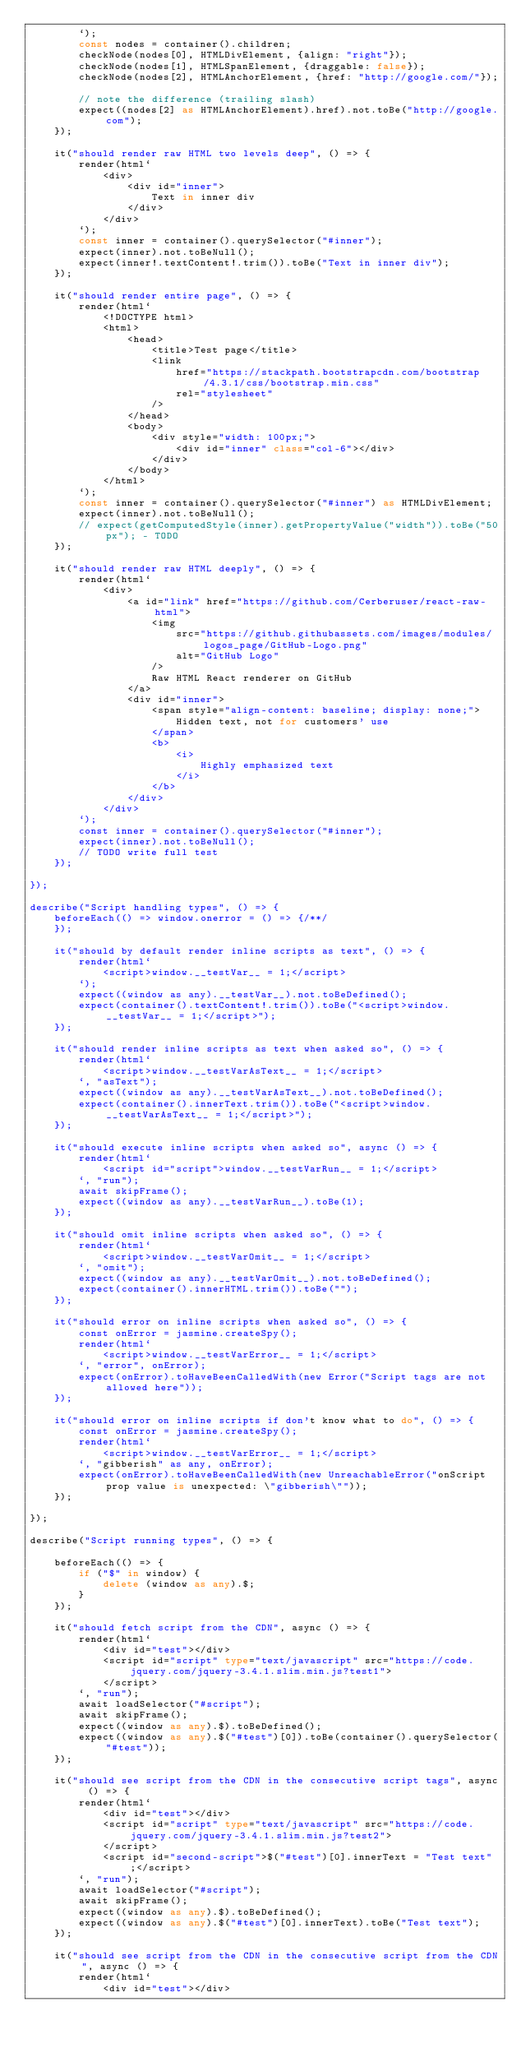Convert code to text. <code><loc_0><loc_0><loc_500><loc_500><_TypeScript_>        `);
        const nodes = container().children;
        checkNode(nodes[0], HTMLDivElement, {align: "right"});
        checkNode(nodes[1], HTMLSpanElement, {draggable: false});
        checkNode(nodes[2], HTMLAnchorElement, {href: "http://google.com/"});

        // note the difference (trailing slash)
        expect((nodes[2] as HTMLAnchorElement).href).not.toBe("http://google.com");
    });

    it("should render raw HTML two levels deep", () => {
        render(html`
            <div>
                <div id="inner">
                    Text in inner div
                </div>
            </div>
        `);
        const inner = container().querySelector("#inner");
        expect(inner).not.toBeNull();
        expect(inner!.textContent!.trim()).toBe("Text in inner div");
    });

    it("should render entire page", () => {
        render(html`
            <!DOCTYPE html>
            <html>
                <head>
                    <title>Test page</title>
                    <link
                        href="https://stackpath.bootstrapcdn.com/bootstrap/4.3.1/css/bootstrap.min.css"
                        rel="stylesheet"
                    />
                </head>
                <body>
                    <div style="width: 100px;">
                        <div id="inner" class="col-6"></div>
                    </div>
                </body>
            </html>
        `);
        const inner = container().querySelector("#inner") as HTMLDivElement;
        expect(inner).not.toBeNull();
        // expect(getComputedStyle(inner).getPropertyValue("width")).toBe("50px"); - TODO
    });

    it("should render raw HTML deeply", () => {
        render(html`
            <div>
                <a id="link" href="https://github.com/Cerberuser/react-raw-html">
                    <img
                        src="https://github.githubassets.com/images/modules/logos_page/GitHub-Logo.png"
                        alt="GitHub Logo"
                    />
                    Raw HTML React renderer on GitHub
                </a>
                <div id="inner">
                    <span style="align-content: baseline; display: none;">
                        Hidden text, not for customers' use
                    </span>
                    <b>
                        <i>
                            Highly emphasized text
                        </i>
                    </b>
                </div>
            </div>
        `);
        const inner = container().querySelector("#inner");
        expect(inner).not.toBeNull();
        // TODO write full test
    });

});

describe("Script handling types", () => {
    beforeEach(() => window.onerror = () => {/**/
    });

    it("should by default render inline scripts as text", () => {
        render(html`
            <script>window.__testVar__ = 1;</script>
        `);
        expect((window as any).__testVar__).not.toBeDefined();
        expect(container().textContent!.trim()).toBe("<script>window.__testVar__ = 1;</script>");
    });

    it("should render inline scripts as text when asked so", () => {
        render(html`
            <script>window.__testVarAsText__ = 1;</script>
        `, "asText");
        expect((window as any).__testVarAsText__).not.toBeDefined();
        expect(container().innerText.trim()).toBe("<script>window.__testVarAsText__ = 1;</script>");
    });

    it("should execute inline scripts when asked so", async () => {
        render(html`
            <script id="script">window.__testVarRun__ = 1;</script>
        `, "run");
        await skipFrame();
        expect((window as any).__testVarRun__).toBe(1);
    });

    it("should omit inline scripts when asked so", () => {
        render(html`
            <script>window.__testVarOmit__ = 1;</script>
        `, "omit");
        expect((window as any).__testVarOmit__).not.toBeDefined();
        expect(container().innerHTML.trim()).toBe("");
    });

    it("should error on inline scripts when asked so", () => {
        const onError = jasmine.createSpy();
        render(html`
            <script>window.__testVarError__ = 1;</script>
        `, "error", onError);
        expect(onError).toHaveBeenCalledWith(new Error("Script tags are not allowed here"));
    });

    it("should error on inline scripts if don't know what to do", () => {
        const onError = jasmine.createSpy();
        render(html`
            <script>window.__testVarError__ = 1;</script>
        `, "gibberish" as any, onError);
        expect(onError).toHaveBeenCalledWith(new UnreachableError("onScript prop value is unexpected: \"gibberish\""));
    });

});

describe("Script running types", () => {

    beforeEach(() => {
        if ("$" in window) {
            delete (window as any).$;
        }
    });

    it("should fetch script from the CDN", async () => {
        render(html`
            <div id="test"></div>
            <script id="script" type="text/javascript" src="https://code.jquery.com/jquery-3.4.1.slim.min.js?test1">
            </script>
        `, "run");
        await loadSelector("#script");
        await skipFrame();
        expect((window as any).$).toBeDefined();
        expect((window as any).$("#test")[0]).toBe(container().querySelector("#test"));
    });

    it("should see script from the CDN in the consecutive script tags", async () => {
        render(html`
            <div id="test"></div>
            <script id="script" type="text/javascript" src="https://code.jquery.com/jquery-3.4.1.slim.min.js?test2">
            </script>
            <script id="second-script">$("#test")[0].innerText = "Test text";</script>
        `, "run");
        await loadSelector("#script");
        await skipFrame();
        expect((window as any).$).toBeDefined();
        expect((window as any).$("#test")[0].innerText).toBe("Test text");
    });

    it("should see script from the CDN in the consecutive script from the CDN", async () => {
        render(html`
            <div id="test"></div></code> 